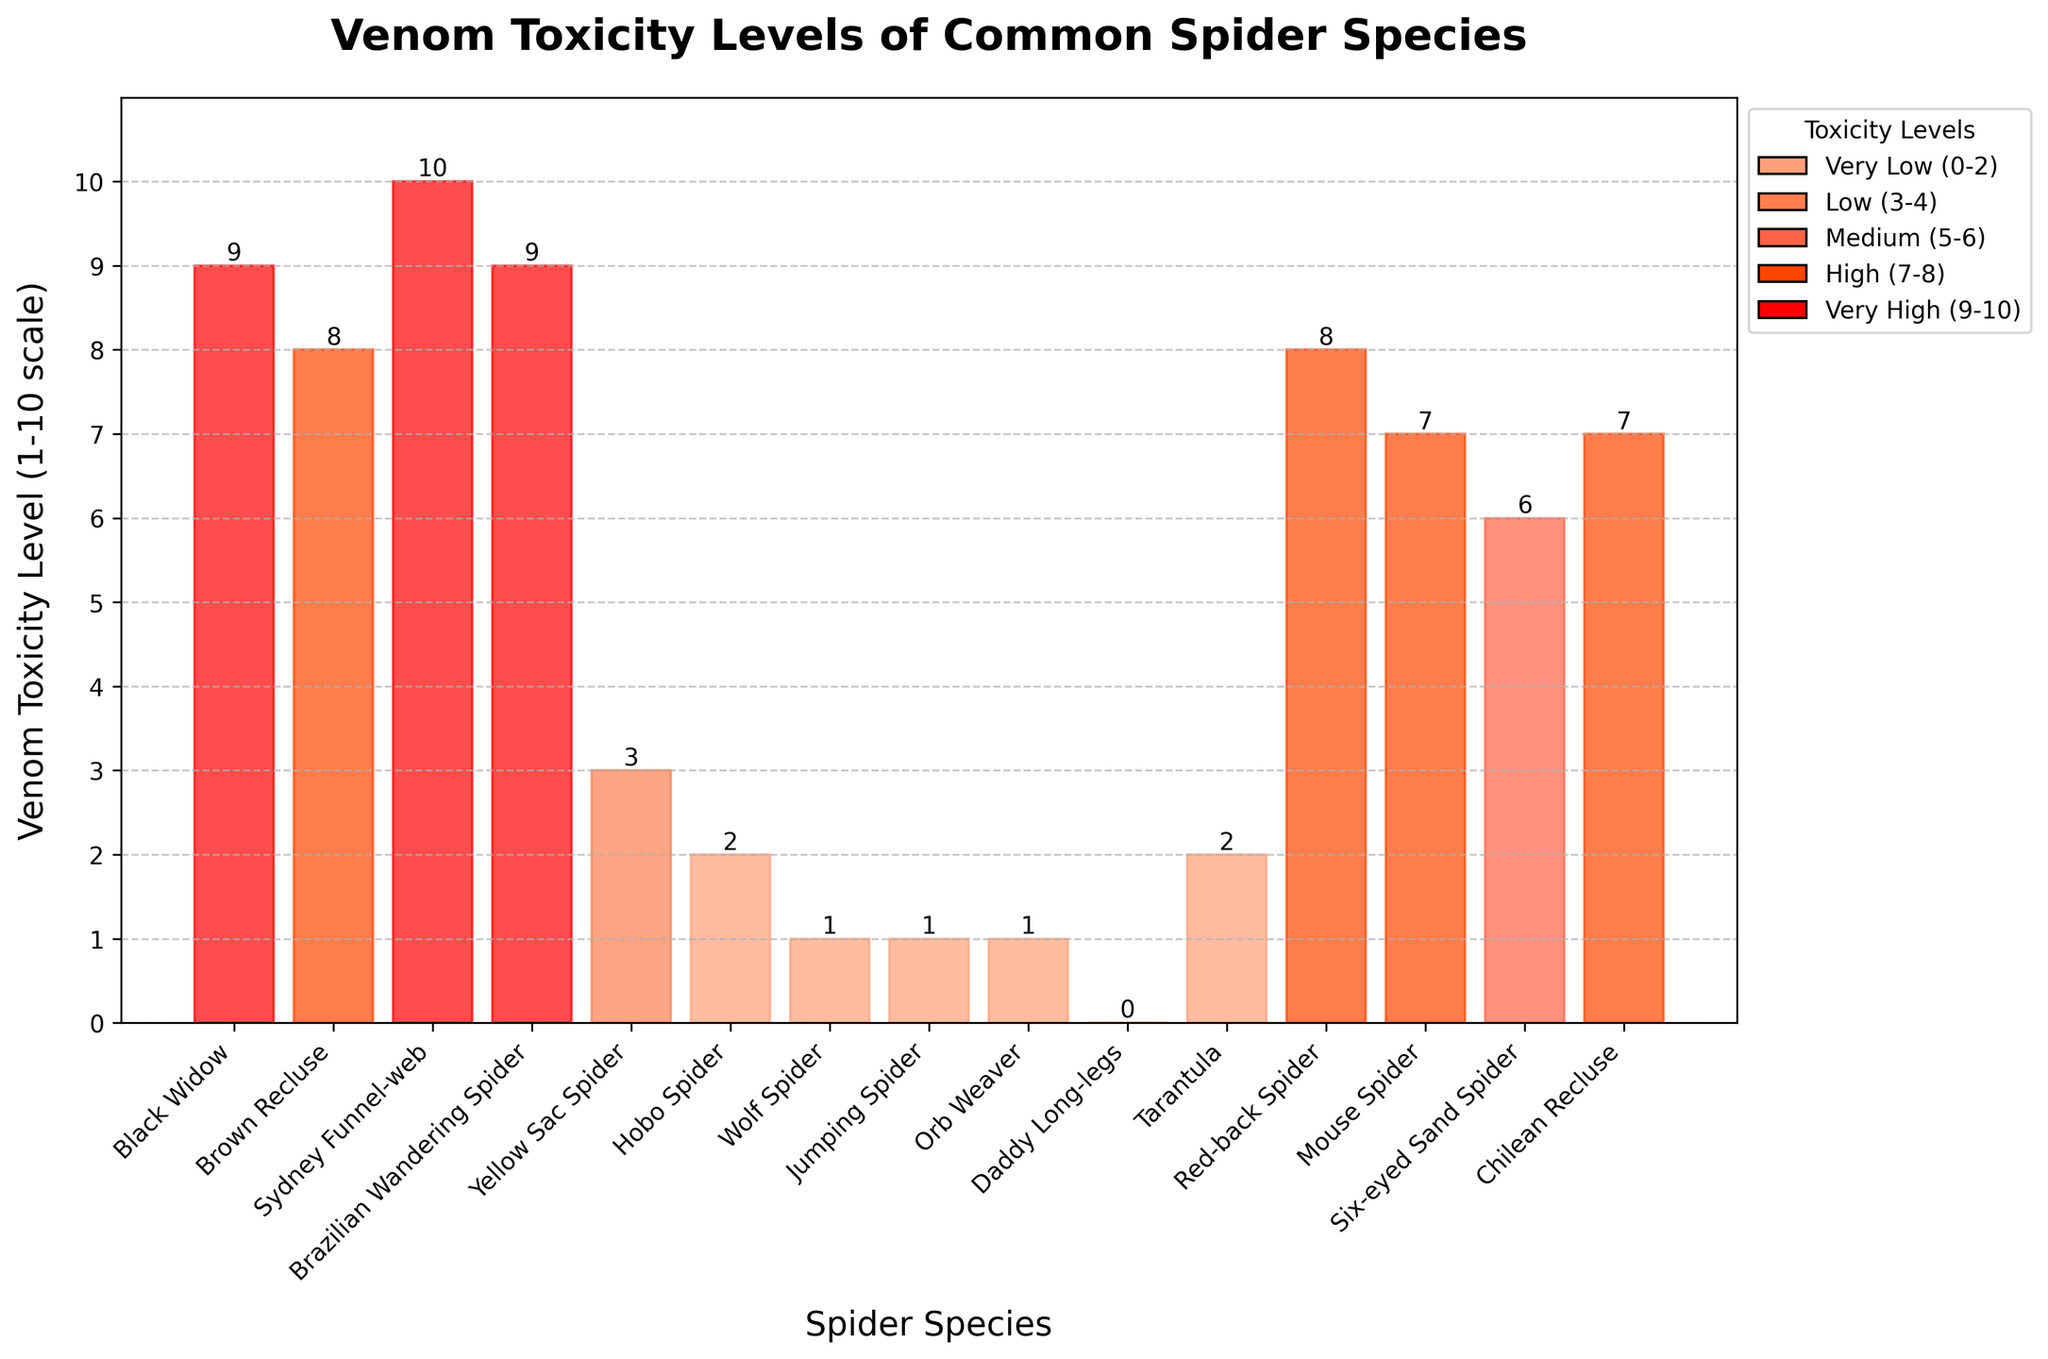Which spider species has the highest venom toxicity level? By looking at the bar chart, observe which bar reaches the highest point on the y-axis. The species corresponding to this bar has the highest venom toxicity level.
Answer: Sydney Funnel-web How many spider species have a venom toxicity level of 1? Examine the bars that end at the y-axis value of 1. Count these bars and note the corresponding spider species.
Answer: Three Is the venom toxicity of the Brown Recluse higher or lower than the Six-eyed Sand Spider? Compare the heights of the bars for Brown Recluse and Six-eyed Sand Spider. The bar that is taller has a higher venom toxicity.
Answer: Higher What's the difference in venom toxicity levels between the Red-back Spider and the Hobo Spider? Identify the bars for Red-back Spider and Hobo Spider and note their respective heights. Subtract the Hobo Spider's toxicity level from the Red-back Spider's toxicity level to find the difference.
Answer: 6 Which spider species has the lowest venom toxicity level? Find the bar that is the shortest on the y-axis. The species corresponding to this bar has the lowest venom toxicity level.
Answer: Daddy Long-legs How many spider species have a venom toxicity level of 7 or higher? Count the bars that reach a y-axis value of 7 or higher. Note the corresponding spider species.
Answer: Seven What's the average venom toxicity level of the Orb Weaver and the Jumping Spider? Identify the venom toxicity levels of Orb Weaver and Jumping Spider. Add these two values together and divide by 2 to get the average.
Answer: 1 Which spider species has the same venom toxicity level as the Mouse Spider? Find the bar at the same height as the Mouse Spider bar and note the corresponding spider species.
Answer: Chilean Recluse 